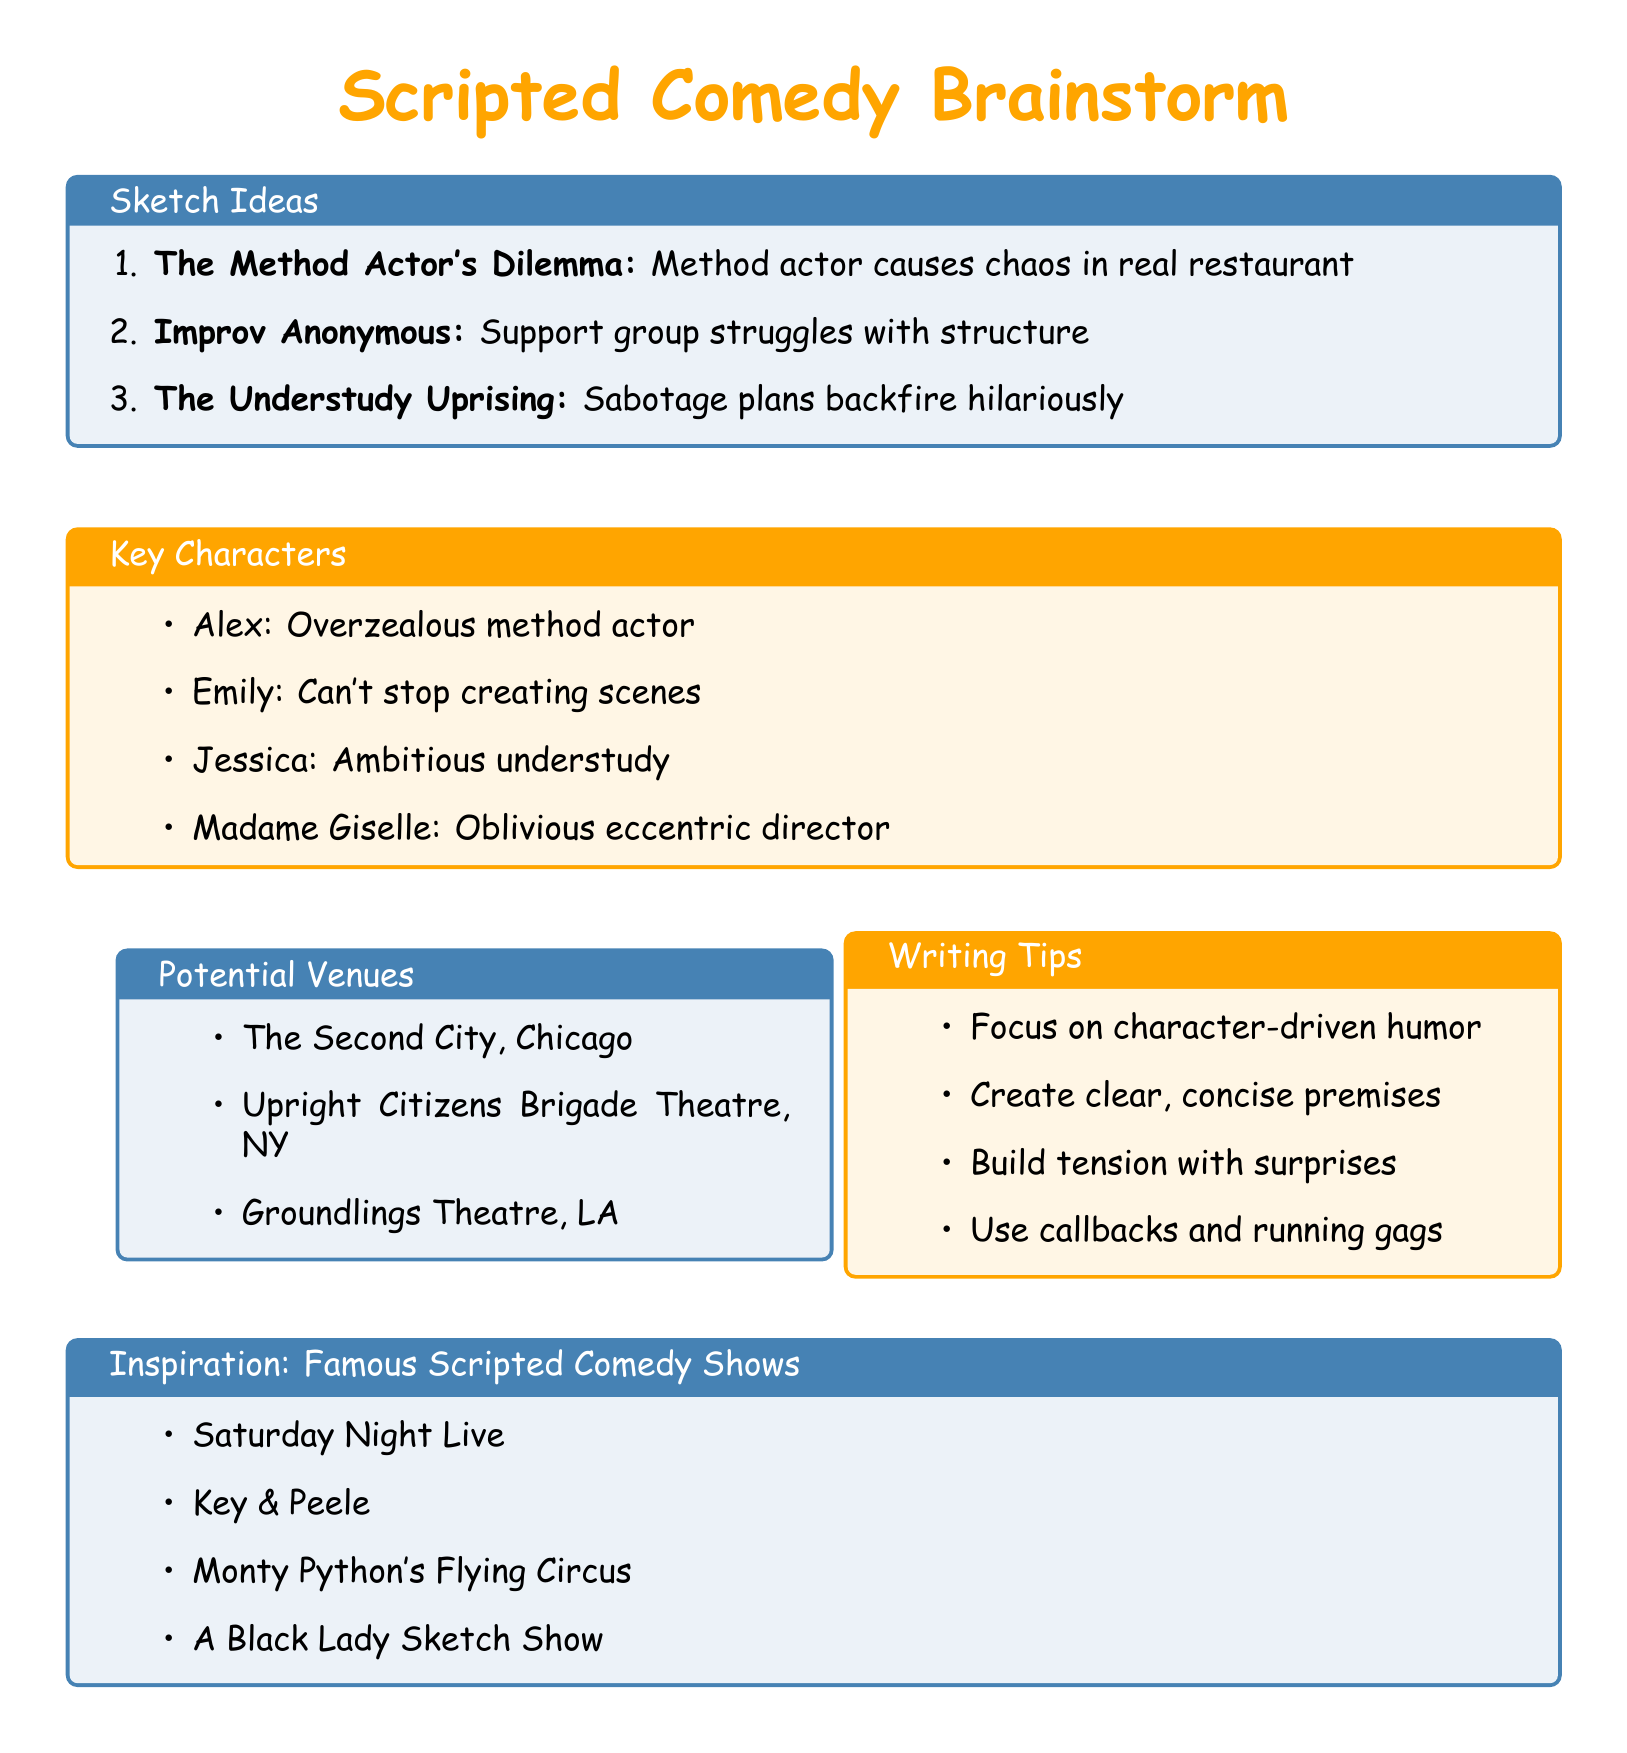What is the title of the first sketch idea? The title of the first sketch is listed under the sketch ideas section as "The Method Actor's Dilemma."
Answer: The Method Actor's Dilemma Who is the frustrated restaurant manager in the first sketch? The character description for the frustrated restaurant manager is listed as "Sarah."
Answer: Sarah How many sketch ideas are listed in total? The total number of sketch ideas is determined by counting the entries in the sketch ideas section, which shows three ideas.
Answer: 3 What is the main theme of "Improv Anonymous"? The plot outline for "Improv Anonymous" specifies that it's about a support group struggling with structure.
Answer: Support group struggles with structure Which character is in denial about his improv addiction? The character known for being in denial about his improv addiction is "Dave" as described in the character list.
Answer: Dave What writing tip emphasizes unexpected elements? The writing tips mention that one should "Build tension and surprise with unexpected twists."
Answer: Build tension and surprise with unexpected twists Name one potential venue for performing the sketches. The potential venues section lists several places, one of which is "The Second City, Chicago."
Answer: The Second City, Chicago Which sketch features an oblivious director? "The Understudy Uprising" features the character described as an eccentric director who is oblivious to chaos.
Answer: The Understudy Uprising What type of humor should the sketches focus on according to the writing tips? The writing tips suggest to "Focus on character-driven humor."
Answer: Character-driven humor 